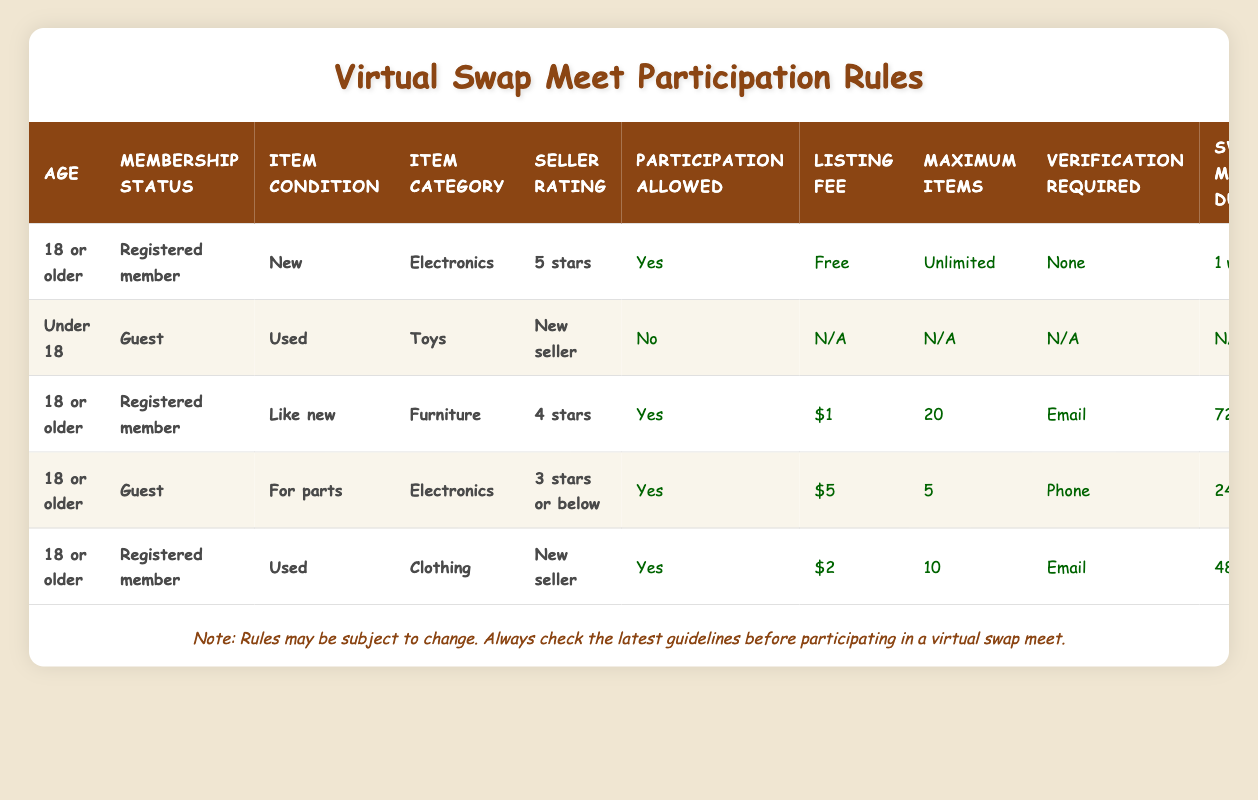What is the participation status for a registered member who is 18 or older and has a 5-star seller rating? According to the table, this specific condition shows that a participant who is 18 or older, a registered member, and has a 5-star seller rating is allowed to participate.
Answer: Yes How many maximum items can a guest with an item condition of "For parts" in electronics and a seller rating of "3 stars or below" list? The table shows that a guest with these specific conditions can list a maximum of 5 items.
Answer: 5 What is the listing fee for a registered member selling used clothing with a new seller rating and is 18 or older? Looking at the conditions where the participant is 18 or older, a registered member, selling used clothing, and is a new seller, the listing fee is $2.
Answer: $2 Is verification required for an 18 or older guest selling "For parts" electronics with a 3-star seller rating? According to the rules in the table, this scenario requires phone verification.
Answer: Yes What is the swap meet duration for a registered member selling "Like new" furniture with a 4-star rating? The table indicates that such a participant can participate for a duration of 72 hours.
Answer: 72 hours How many sellers have participation allowed as "Yes" in total? Reviewing the table, the rows that allow participation are counted: there are 4 sellers (those that have "Yes" in the participation allowed column).
Answer: 4 What condition must be met for a guest under 18 to participate in the swap meet? According to the table, no conditions allow for participation by guests under 18. Their participation is not permitted regardless of item conditions or seller ratings.
Answer: No What is the listing fee for a registered member 18 or older selling new electronics with a 5-star seller rating? The table clearly states that this condition allows participation with no listing fee.
Answer: Free 